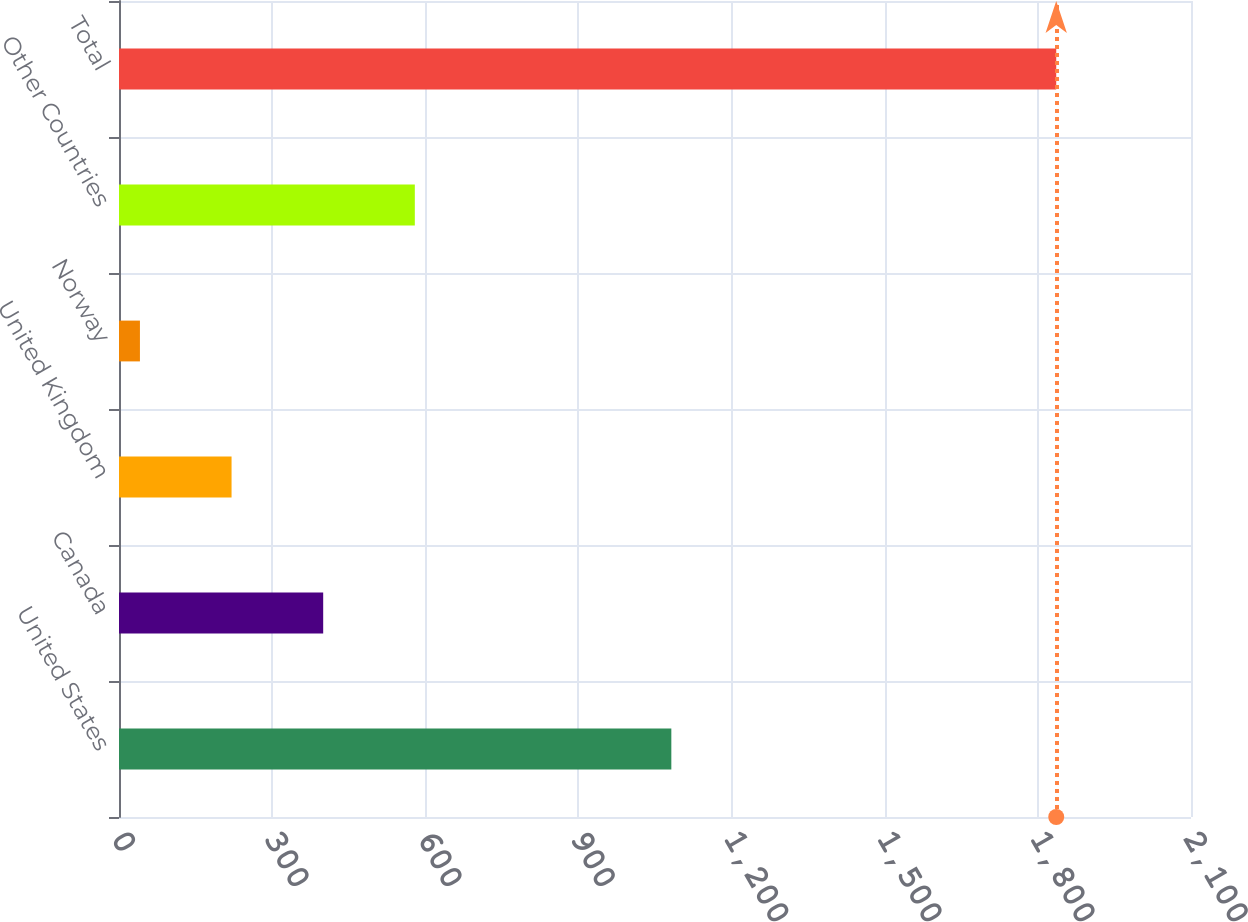Convert chart to OTSL. <chart><loc_0><loc_0><loc_500><loc_500><bar_chart><fcel>United States<fcel>Canada<fcel>United Kingdom<fcel>Norway<fcel>Other Countries<fcel>Total<nl><fcel>1082<fcel>400<fcel>220.5<fcel>41<fcel>579.5<fcel>1836<nl></chart> 